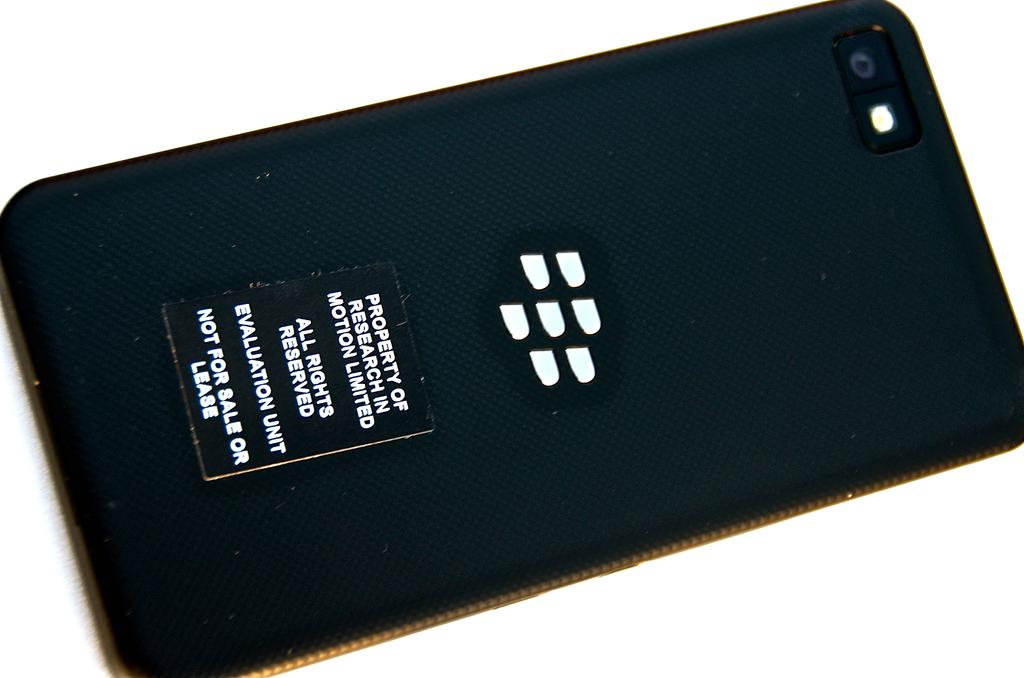<image>
Relay a brief, clear account of the picture shown. a phone with the line property of research on it 